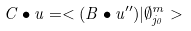Convert formula to latex. <formula><loc_0><loc_0><loc_500><loc_500>C \bullet u = < ( B \bullet u ^ { \prime \prime } ) | \emptyset _ { j _ { 0 } } ^ { m } ></formula> 